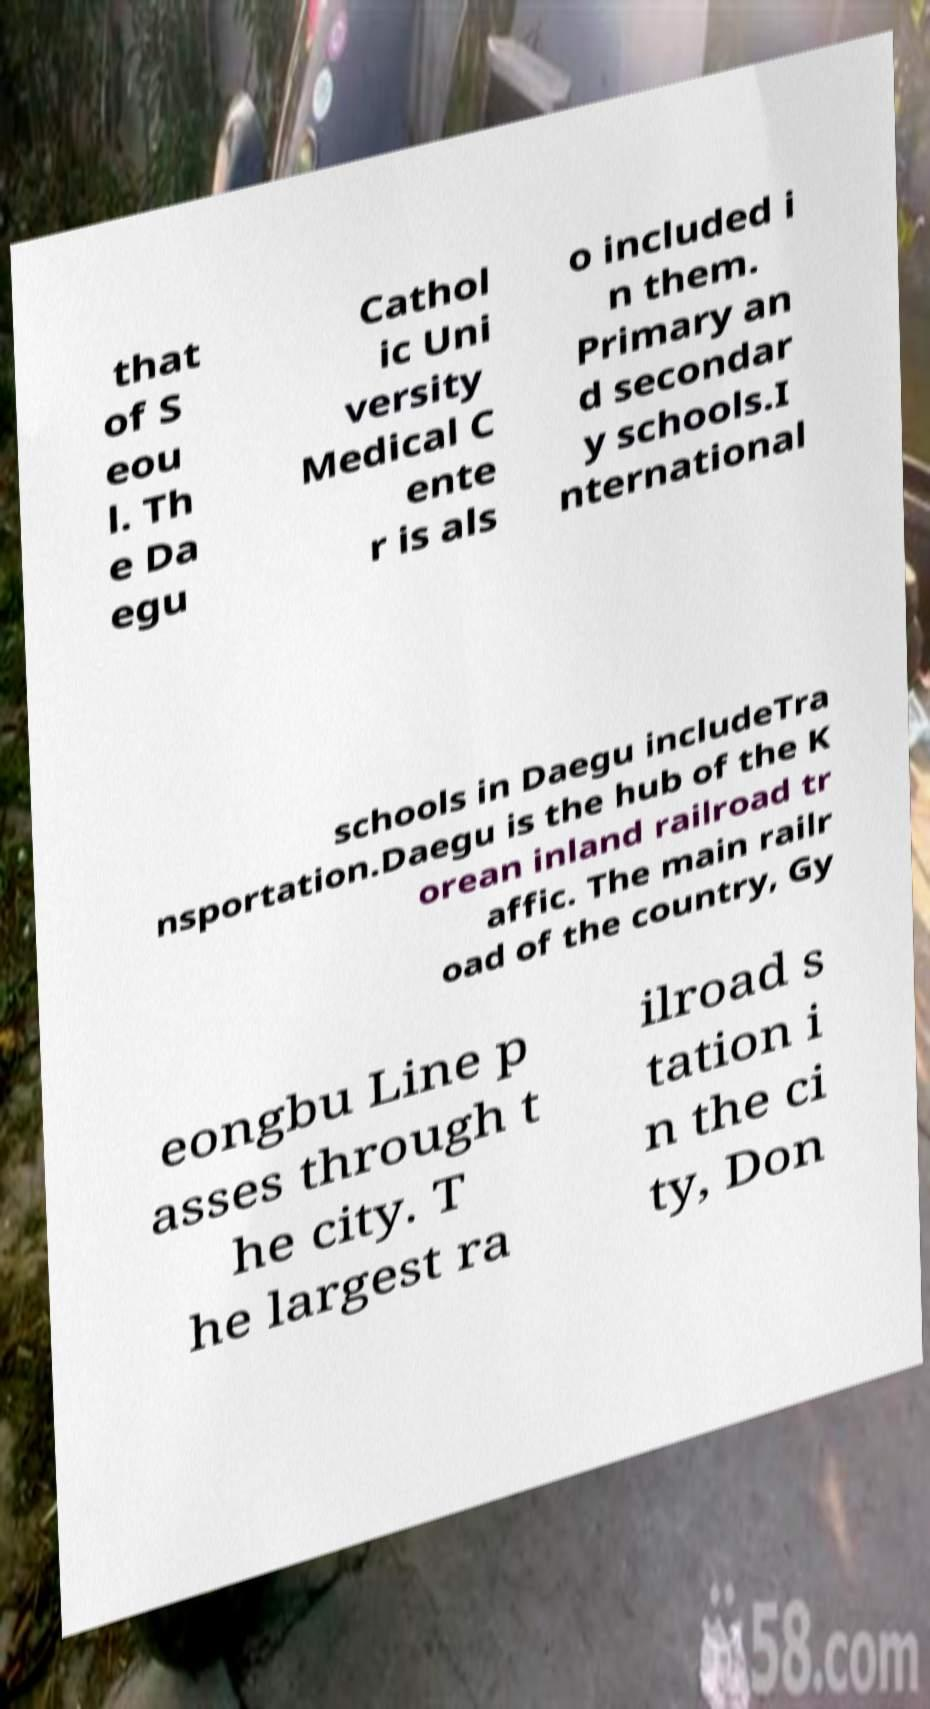What messages or text are displayed in this image? I need them in a readable, typed format. that of S eou l. Th e Da egu Cathol ic Uni versity Medical C ente r is als o included i n them. Primary an d secondar y schools.I nternational schools in Daegu includeTra nsportation.Daegu is the hub of the K orean inland railroad tr affic. The main railr oad of the country, Gy eongbu Line p asses through t he city. T he largest ra ilroad s tation i n the ci ty, Don 